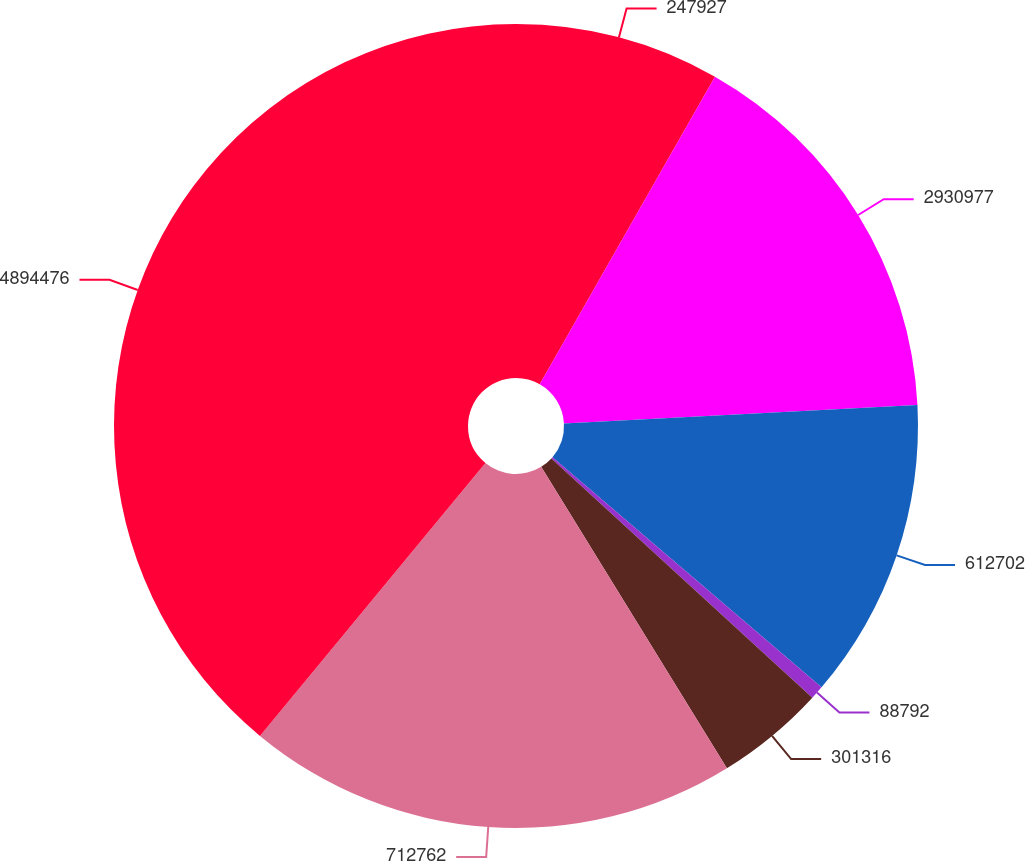Convert chart to OTSL. <chart><loc_0><loc_0><loc_500><loc_500><pie_chart><fcel>247927<fcel>2930977<fcel>612702<fcel>88792<fcel>301316<fcel>712762<fcel>4894476<nl><fcel>8.24%<fcel>15.93%<fcel>12.09%<fcel>0.55%<fcel>4.4%<fcel>19.78%<fcel>39.01%<nl></chart> 